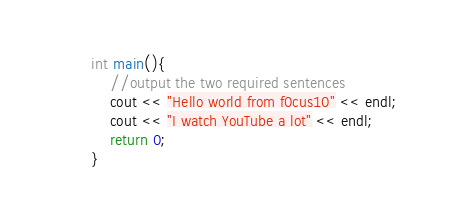Convert code to text. <code><loc_0><loc_0><loc_500><loc_500><_C++_>int main(){
	//output the two required sentences
	cout << "Hello world from f0cus10" << endl;
	cout << "I watch YouTube a lot" << endl;
	return 0;
}
</code> 